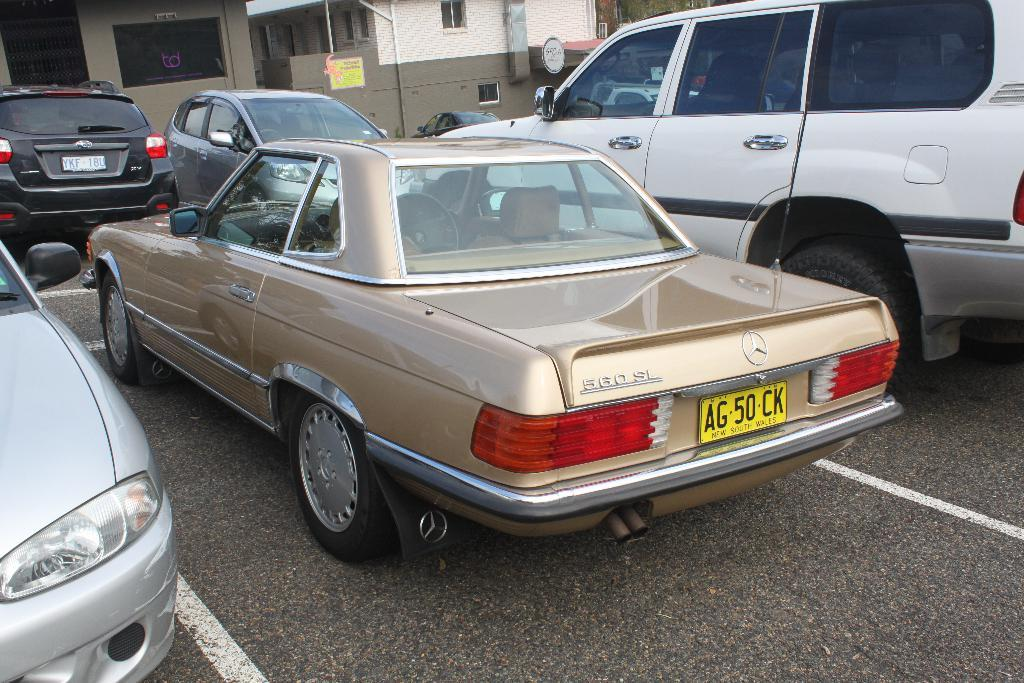What can be seen on the road in the image? There are cars parked on the road in the image. What can be seen in the distance behind the parked cars? There are buildings visible in the background of the image. What attempt is being made to put out the fire in the image? There is no fire present in the image, so no attempt is being made to put it out. 